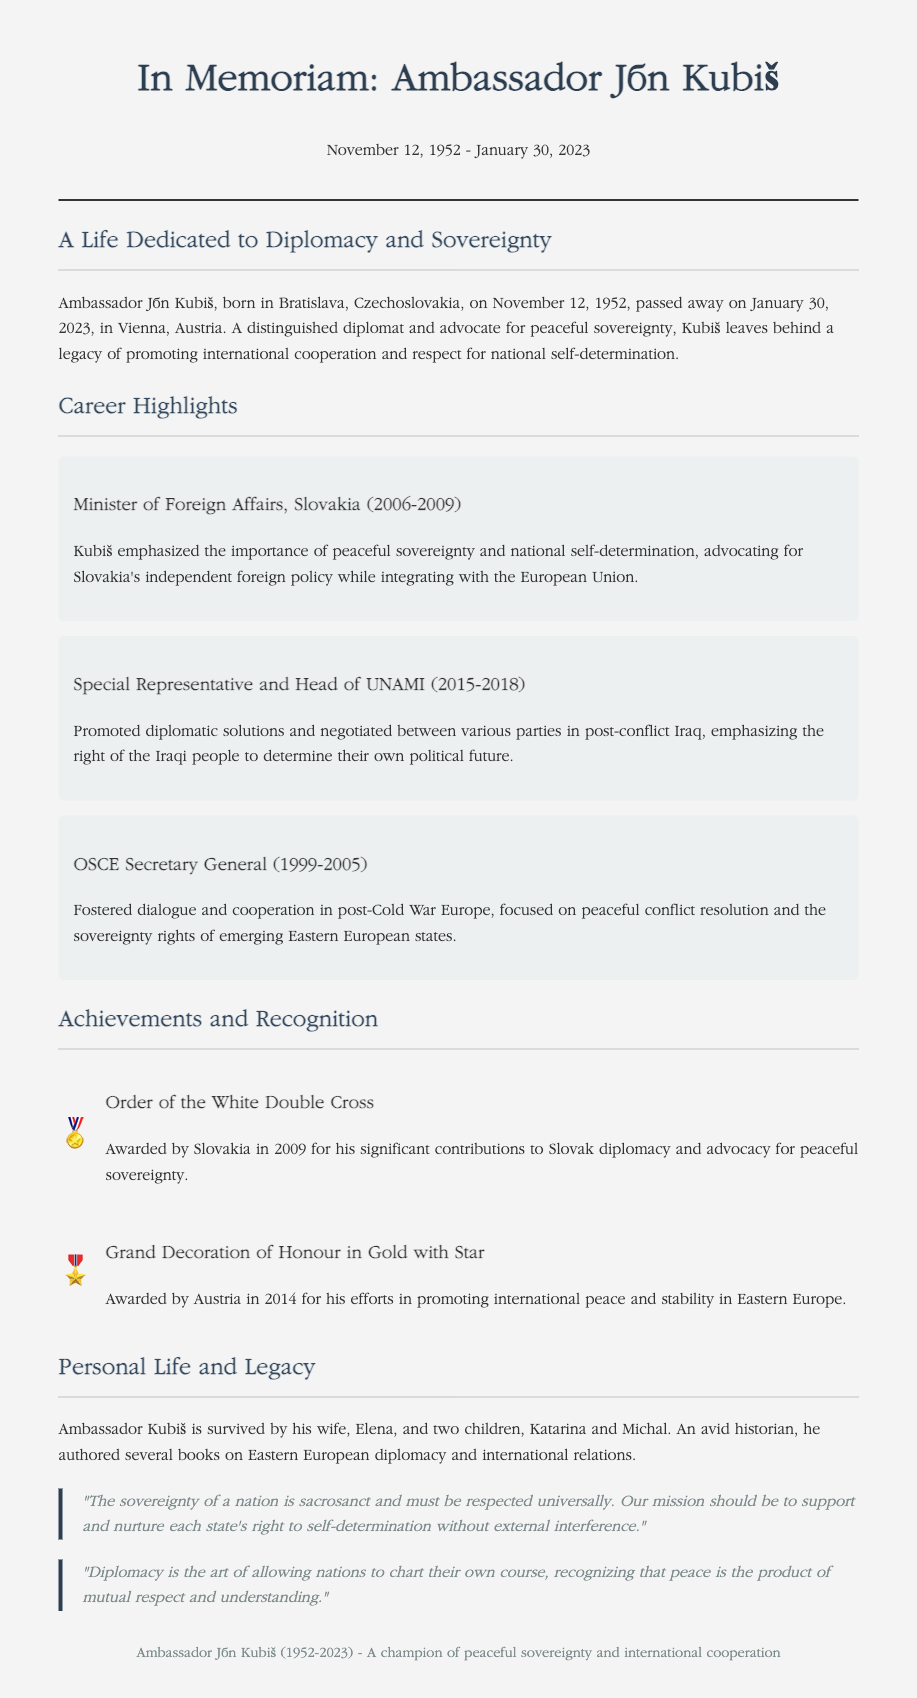What was the birth date of Ambassador Ján Kubiš? The document states that he was born on November 12, 1952.
Answer: November 12, 1952 In which city did Ambassador Ján Kubiš pass away? The obituary mentions that he passed away in Vienna, Austria.
Answer: Vienna, Austria What position did Kubiš hold from 2006 to 2009? The document specifies that he was the Minister of Foreign Affairs of Slovakia during that time.
Answer: Minister of Foreign Affairs, Slovakia Which award did he receive from Slovakia in 2009? The document states that he was awarded the Order of the White Double Cross.
Answer: Order of the White Double Cross What was Kubiš’s view on the sovereignty of nations? The document includes a quote emphasizing that "The sovereignty of a nation is sacrosanct and must be respected universally."
Answer: Sacrosanct What role did Kubiš play in Iraq from 2015 to 2018? The article describes him as the Special Representative and Head of UNAMI during that time.
Answer: Special Representative and Head of UNAMI What is a highlighted theme of Kubiš's career? The obituary emphasizes his advocacy for peaceful sovereignty and national self-determination.
Answer: Peaceful sovereignty How many children did Ambassador Kubiš have? The document indicates he had two children.
Answer: Two 